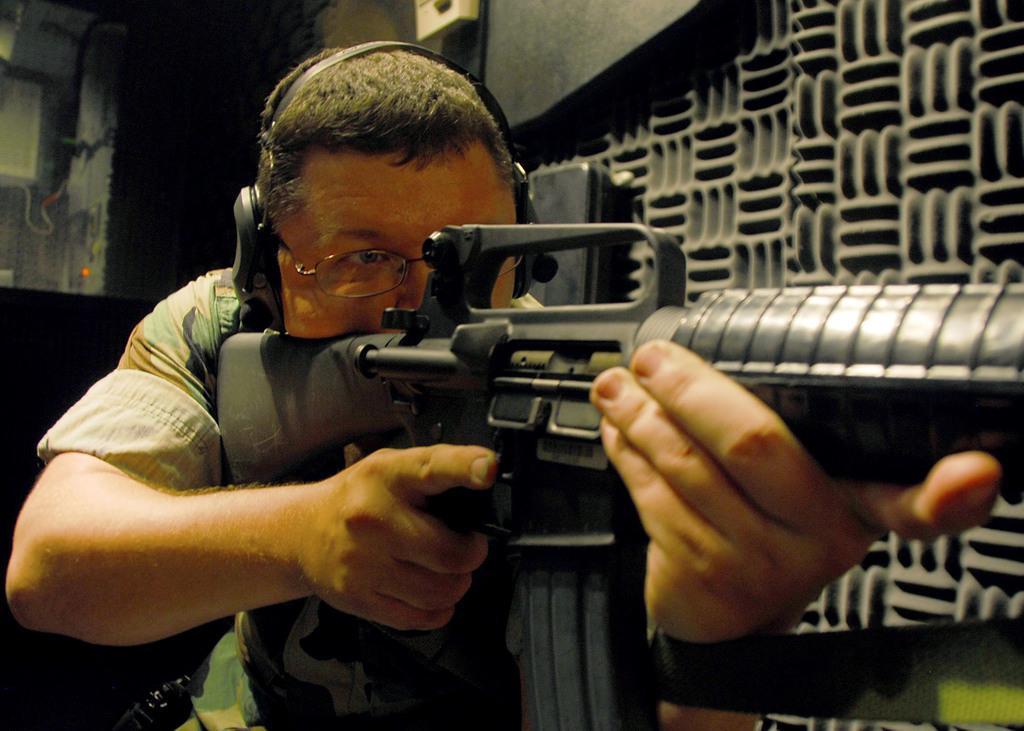Please provide a concise description of this image. In the center of the image a man is wearing headset spectacles and holding a gun. In the background of the image we can see wall, mirror, board. Through mirror we can see some objects. 